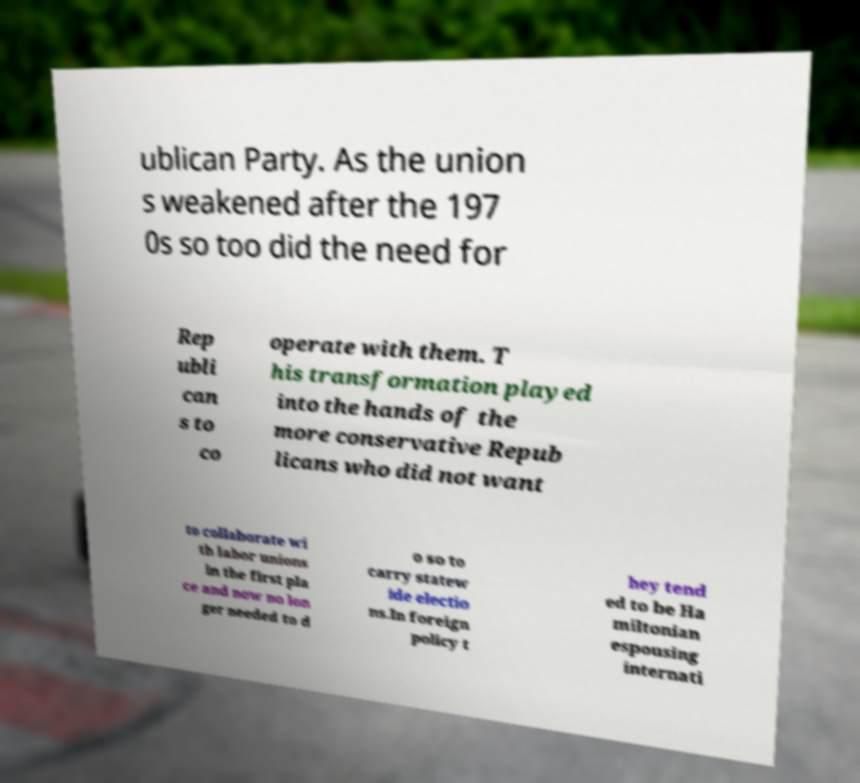There's text embedded in this image that I need extracted. Can you transcribe it verbatim? ublican Party. As the union s weakened after the 197 0s so too did the need for Rep ubli can s to co operate with them. T his transformation played into the hands of the more conservative Repub licans who did not want to collaborate wi th labor unions in the first pla ce and now no lon ger needed to d o so to carry statew ide electio ns.In foreign policy t hey tend ed to be Ha miltonian espousing internati 